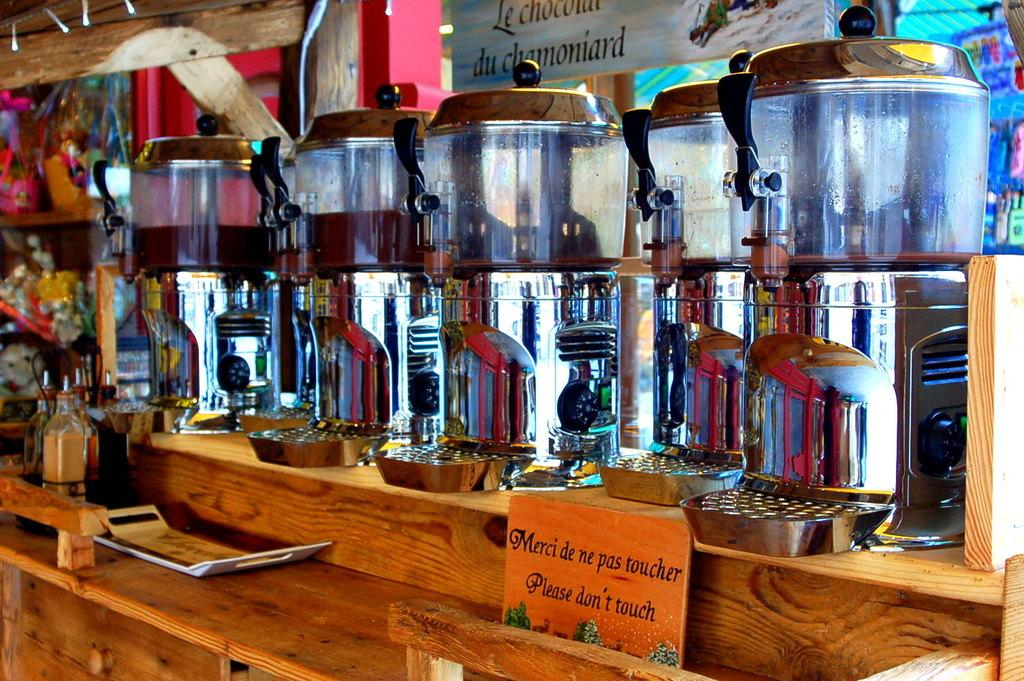<image>
Give a short and clear explanation of the subsequent image. A few machines with a sign saying in English and French to not touch 